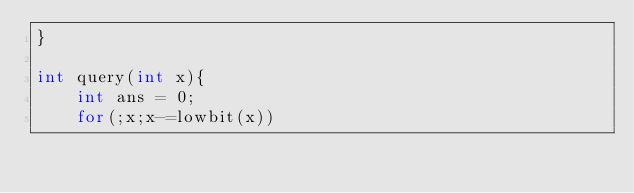Convert code to text. <code><loc_0><loc_0><loc_500><loc_500><_C++_>}

int query(int x){
	int ans = 0;
	for(;x;x-=lowbit(x))</code> 